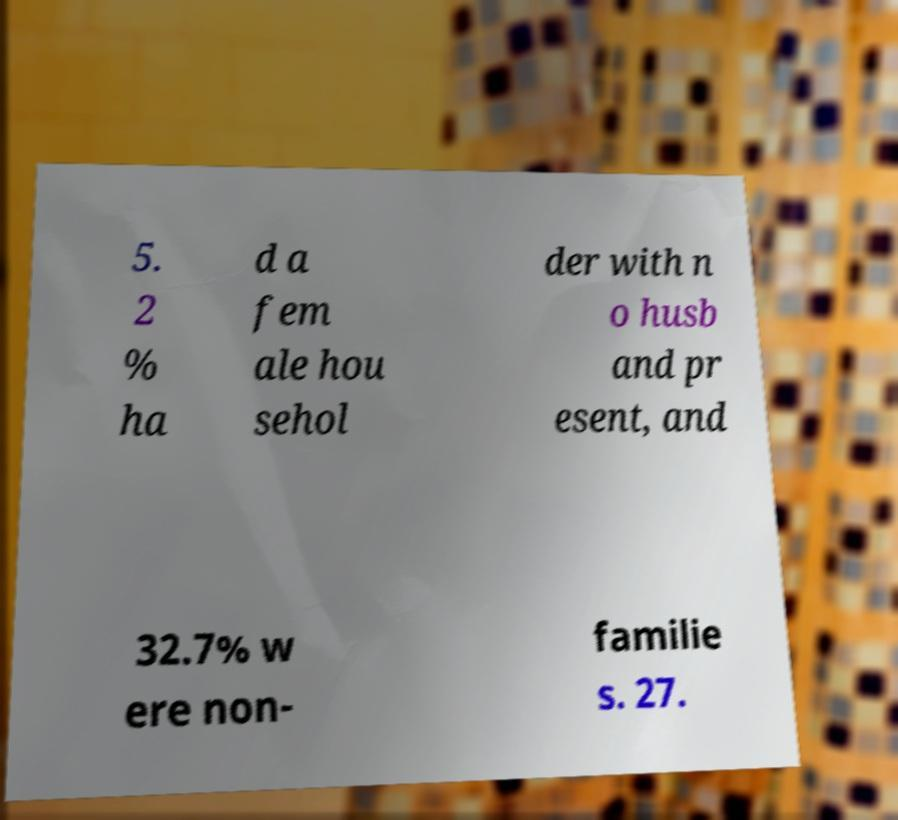There's text embedded in this image that I need extracted. Can you transcribe it verbatim? 5. 2 % ha d a fem ale hou sehol der with n o husb and pr esent, and 32.7% w ere non- familie s. 27. 